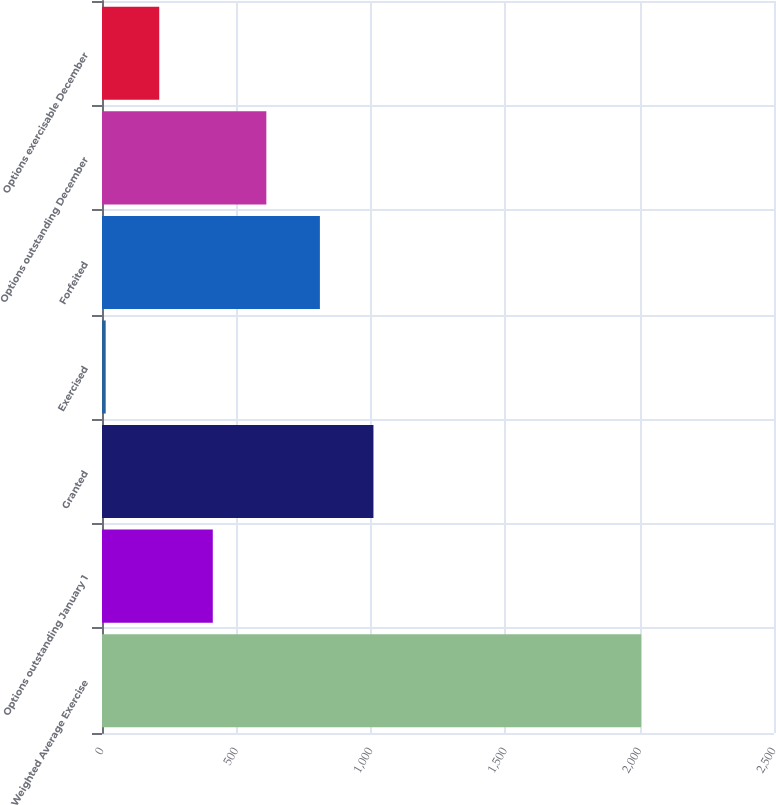Convert chart to OTSL. <chart><loc_0><loc_0><loc_500><loc_500><bar_chart><fcel>Weighted Average Exercise<fcel>Options outstanding January 1<fcel>Granted<fcel>Exercised<fcel>Forfeited<fcel>Options outstanding December<fcel>Options exercisable December<nl><fcel>2006<fcel>412.15<fcel>1009.84<fcel>13.69<fcel>810.61<fcel>611.38<fcel>212.92<nl></chart> 